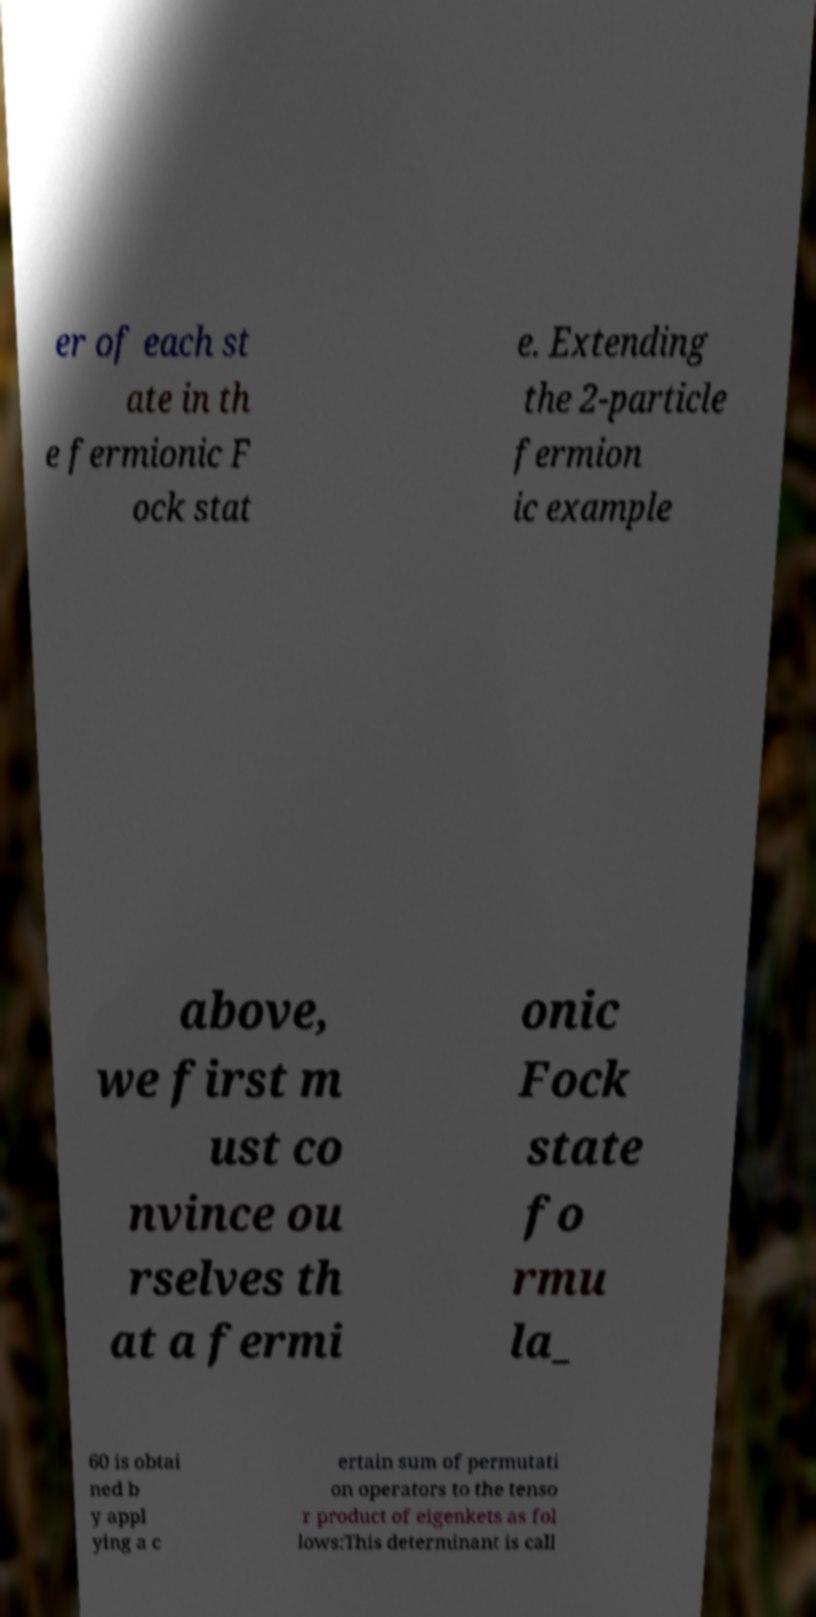There's text embedded in this image that I need extracted. Can you transcribe it verbatim? er of each st ate in th e fermionic F ock stat e. Extending the 2-particle fermion ic example above, we first m ust co nvince ou rselves th at a fermi onic Fock state fo rmu la_ 60 is obtai ned b y appl ying a c ertain sum of permutati on operators to the tenso r product of eigenkets as fol lows:This determinant is call 